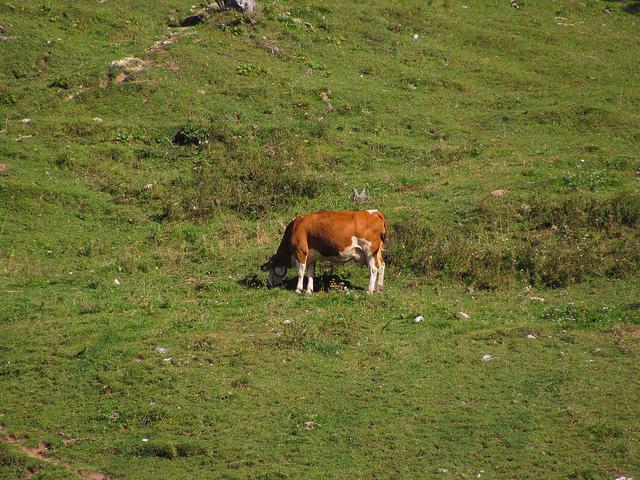How many people are playing baseball in the picture?
Give a very brief answer. 0. 